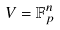Convert formula to latex. <formula><loc_0><loc_0><loc_500><loc_500>V = \mathbb { F } _ { p } ^ { n }</formula> 